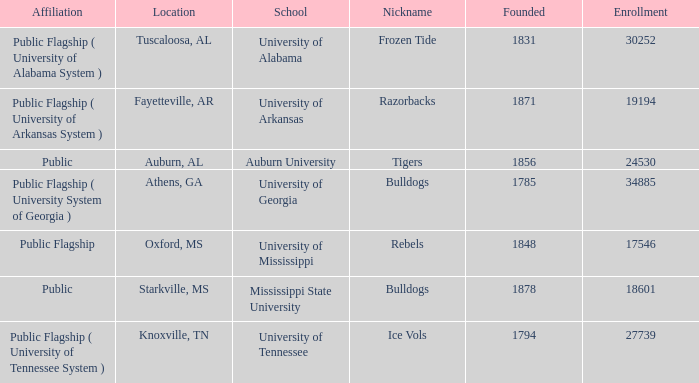What is the nickname of the University of Alabama? Frozen Tide. 